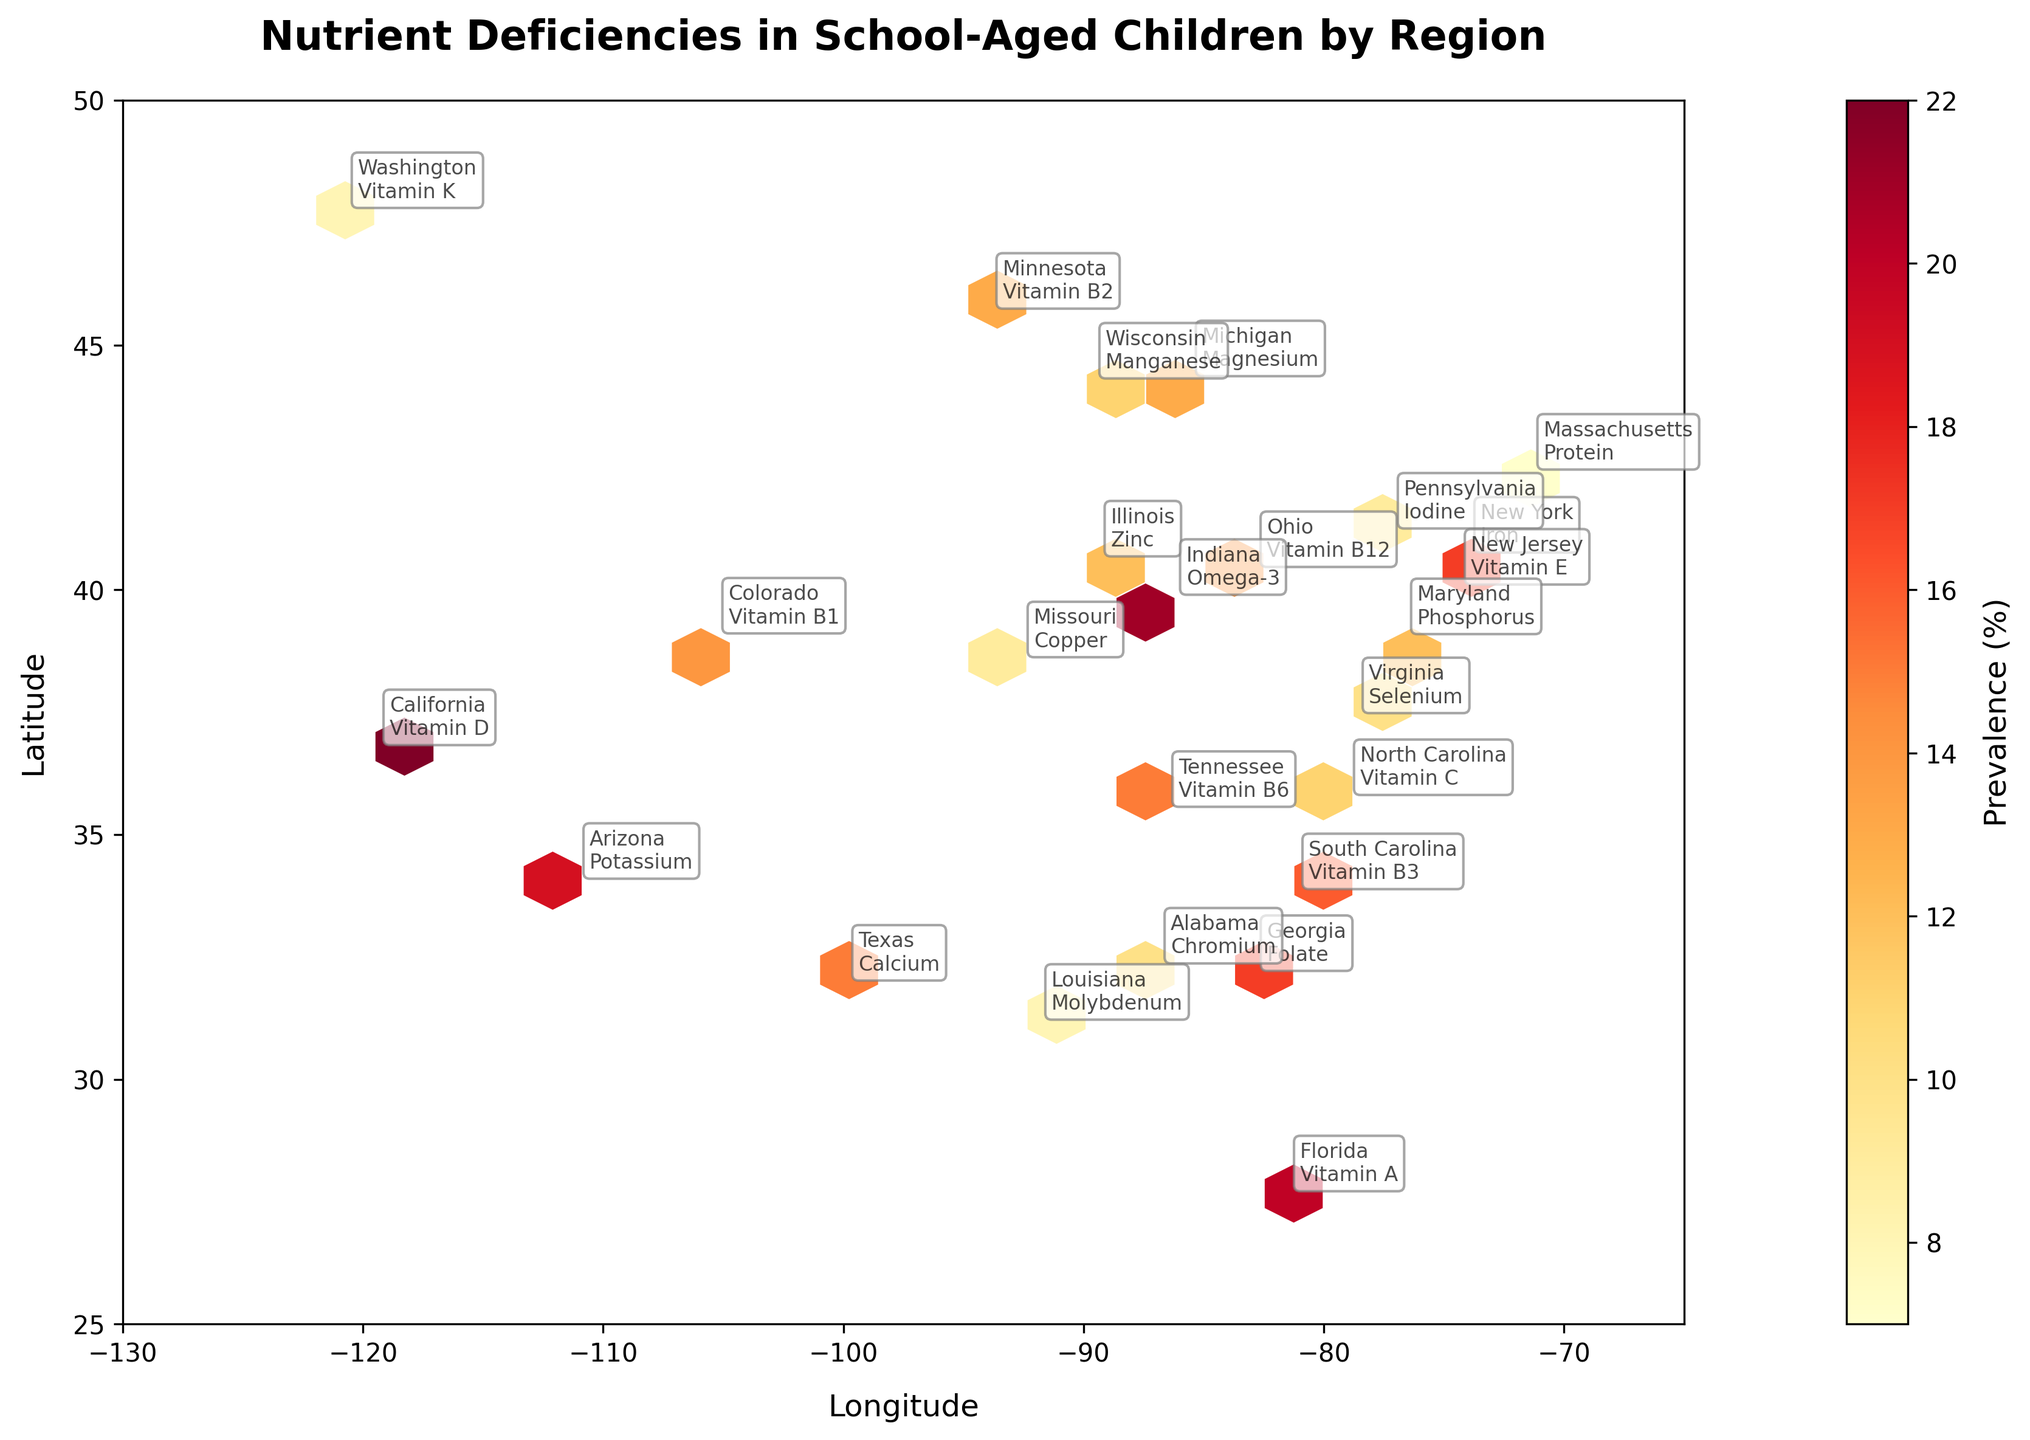What is the title of the plot? The title is located at the top of the plot area and usually written in a larger and bold font.
Answer: Nutrient Deficiencies in School-Aged Children by Region What does the color bar represent? The color bar, usually on the side of the plot, indicates the prevalence (%) of nutrient deficiencies.
Answer: Prevalence (%) Which geographical region is most affected by Vitamin D deficiency? By looking at the annotations on the plot, we can see the names of the regions and the type of nutrient deficiency noted beside them.
Answer: California How many regions have a prevalence of 15% or more? From the color bar, identify the color range representing 15% or more, then count the number of regions using those colors.
Answer: 10 regions Which region shows the lowest prevalence of nutrient deficiency and what is the deficiency? The region with the lightest color hexagon can be cross-referenced with the annotations to identify both the region and the nutrient.
Answer: Massachusetts, Protein Among the nutrient deficiencies, which one appears in the most number of regions? By checking the annotations for each region systematically, count the occurrences of each nutrient deficiency to find the most frequent one.
Answer: No specific deficiency, all are different Compare the prevalence of nutrient deficiency of New York and California. Which one is higher and by how much? The prevalence of New York (Iron) is 18%, and California (Vitamin D) is 22%. Subtract 18 from 22.
Answer: California, by 4% What is the average prevalence of nutrient deficiencies across all regions? Add up all the prevalence values and then divide by the number of regions (24).
Answer: Approx. 13.7% What is the difference in prevalence between the regions with the highest and lowest deficiencies? Identify the regions with highest (California, 22%) and lowest (Massachusetts, 7%) prevalence, then subtract to find the difference.
Answer: 15% How is the geographical distribution of nutrient deficiencies visualized in the hexbin plot? The hexbin plot uses different colors within hexagonal bins to represent the density (prevalence %) of the nutrient deficiencies across geographical coordinates (latitude and longitude).
Answer: By hexagonal bins with color gradients representing prevalence 